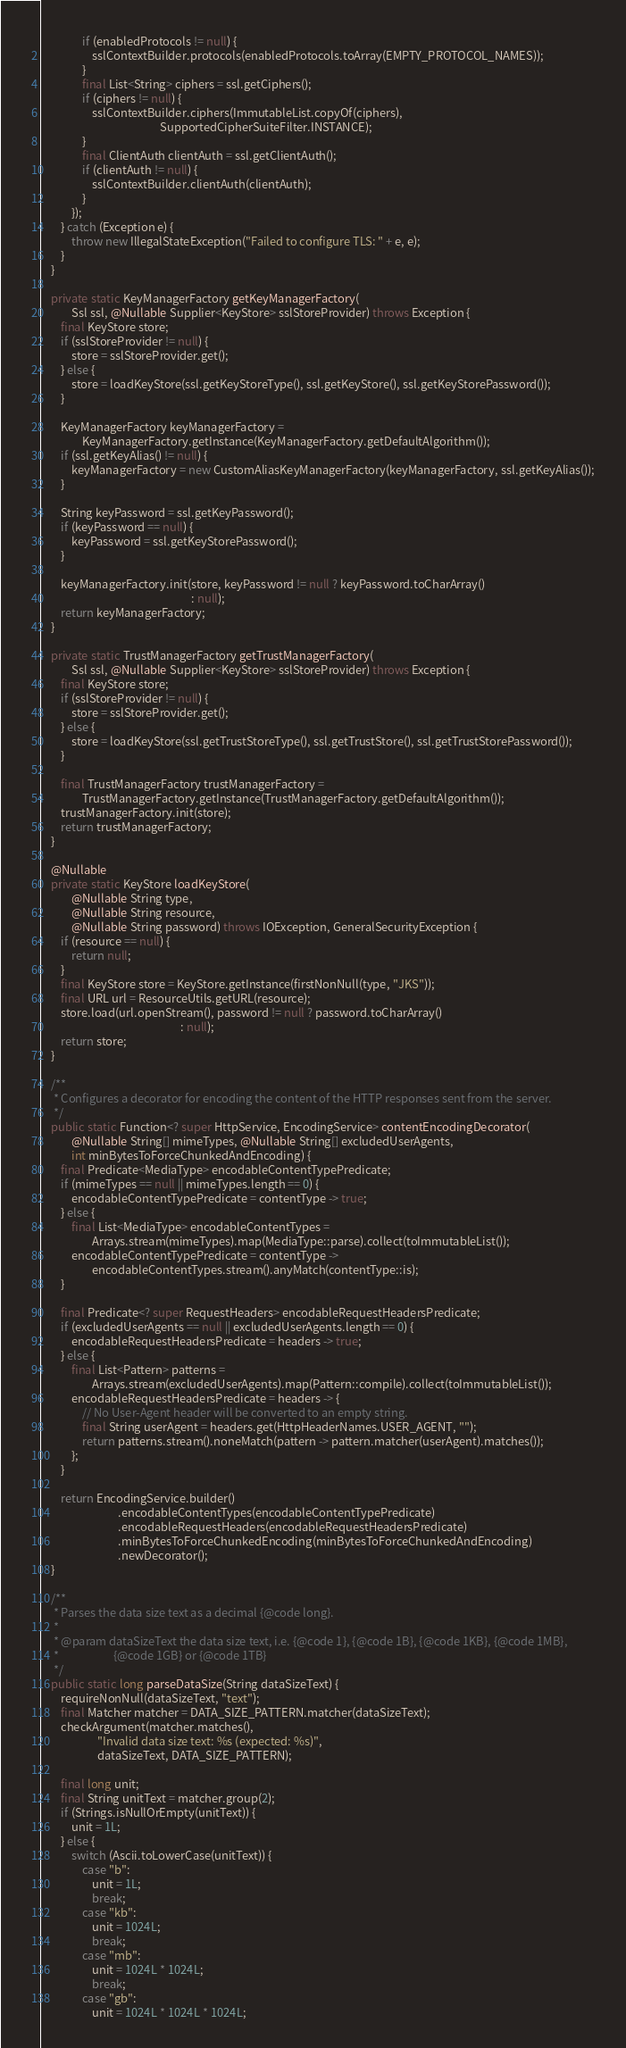Convert code to text. <code><loc_0><loc_0><loc_500><loc_500><_Java_>                if (enabledProtocols != null) {
                    sslContextBuilder.protocols(enabledProtocols.toArray(EMPTY_PROTOCOL_NAMES));
                }
                final List<String> ciphers = ssl.getCiphers();
                if (ciphers != null) {
                    sslContextBuilder.ciphers(ImmutableList.copyOf(ciphers),
                                              SupportedCipherSuiteFilter.INSTANCE);
                }
                final ClientAuth clientAuth = ssl.getClientAuth();
                if (clientAuth != null) {
                    sslContextBuilder.clientAuth(clientAuth);
                }
            });
        } catch (Exception e) {
            throw new IllegalStateException("Failed to configure TLS: " + e, e);
        }
    }

    private static KeyManagerFactory getKeyManagerFactory(
            Ssl ssl, @Nullable Supplier<KeyStore> sslStoreProvider) throws Exception {
        final KeyStore store;
        if (sslStoreProvider != null) {
            store = sslStoreProvider.get();
        } else {
            store = loadKeyStore(ssl.getKeyStoreType(), ssl.getKeyStore(), ssl.getKeyStorePassword());
        }

        KeyManagerFactory keyManagerFactory =
                KeyManagerFactory.getInstance(KeyManagerFactory.getDefaultAlgorithm());
        if (ssl.getKeyAlias() != null) {
            keyManagerFactory = new CustomAliasKeyManagerFactory(keyManagerFactory, ssl.getKeyAlias());
        }

        String keyPassword = ssl.getKeyPassword();
        if (keyPassword == null) {
            keyPassword = ssl.getKeyStorePassword();
        }

        keyManagerFactory.init(store, keyPassword != null ? keyPassword.toCharArray()
                                                          : null);
        return keyManagerFactory;
    }

    private static TrustManagerFactory getTrustManagerFactory(
            Ssl ssl, @Nullable Supplier<KeyStore> sslStoreProvider) throws Exception {
        final KeyStore store;
        if (sslStoreProvider != null) {
            store = sslStoreProvider.get();
        } else {
            store = loadKeyStore(ssl.getTrustStoreType(), ssl.getTrustStore(), ssl.getTrustStorePassword());
        }

        final TrustManagerFactory trustManagerFactory =
                TrustManagerFactory.getInstance(TrustManagerFactory.getDefaultAlgorithm());
        trustManagerFactory.init(store);
        return trustManagerFactory;
    }

    @Nullable
    private static KeyStore loadKeyStore(
            @Nullable String type,
            @Nullable String resource,
            @Nullable String password) throws IOException, GeneralSecurityException {
        if (resource == null) {
            return null;
        }
        final KeyStore store = KeyStore.getInstance(firstNonNull(type, "JKS"));
        final URL url = ResourceUtils.getURL(resource);
        store.load(url.openStream(), password != null ? password.toCharArray()
                                                      : null);
        return store;
    }

    /**
     * Configures a decorator for encoding the content of the HTTP responses sent from the server.
     */
    public static Function<? super HttpService, EncodingService> contentEncodingDecorator(
            @Nullable String[] mimeTypes, @Nullable String[] excludedUserAgents,
            int minBytesToForceChunkedAndEncoding) {
        final Predicate<MediaType> encodableContentTypePredicate;
        if (mimeTypes == null || mimeTypes.length == 0) {
            encodableContentTypePredicate = contentType -> true;
        } else {
            final List<MediaType> encodableContentTypes =
                    Arrays.stream(mimeTypes).map(MediaType::parse).collect(toImmutableList());
            encodableContentTypePredicate = contentType ->
                    encodableContentTypes.stream().anyMatch(contentType::is);
        }

        final Predicate<? super RequestHeaders> encodableRequestHeadersPredicate;
        if (excludedUserAgents == null || excludedUserAgents.length == 0) {
            encodableRequestHeadersPredicate = headers -> true;
        } else {
            final List<Pattern> patterns =
                    Arrays.stream(excludedUserAgents).map(Pattern::compile).collect(toImmutableList());
            encodableRequestHeadersPredicate = headers -> {
                // No User-Agent header will be converted to an empty string.
                final String userAgent = headers.get(HttpHeaderNames.USER_AGENT, "");
                return patterns.stream().noneMatch(pattern -> pattern.matcher(userAgent).matches());
            };
        }

        return EncodingService.builder()
                              .encodableContentTypes(encodableContentTypePredicate)
                              .encodableRequestHeaders(encodableRequestHeadersPredicate)
                              .minBytesToForceChunkedEncoding(minBytesToForceChunkedAndEncoding)
                              .newDecorator();
    }

    /**
     * Parses the data size text as a decimal {@code long}.
     *
     * @param dataSizeText the data size text, i.e. {@code 1}, {@code 1B}, {@code 1KB}, {@code 1MB},
     *                     {@code 1GB} or {@code 1TB}
     */
    public static long parseDataSize(String dataSizeText) {
        requireNonNull(dataSizeText, "text");
        final Matcher matcher = DATA_SIZE_PATTERN.matcher(dataSizeText);
        checkArgument(matcher.matches(),
                      "Invalid data size text: %s (expected: %s)",
                      dataSizeText, DATA_SIZE_PATTERN);

        final long unit;
        final String unitText = matcher.group(2);
        if (Strings.isNullOrEmpty(unitText)) {
            unit = 1L;
        } else {
            switch (Ascii.toLowerCase(unitText)) {
                case "b":
                    unit = 1L;
                    break;
                case "kb":
                    unit = 1024L;
                    break;
                case "mb":
                    unit = 1024L * 1024L;
                    break;
                case "gb":
                    unit = 1024L * 1024L * 1024L;</code> 